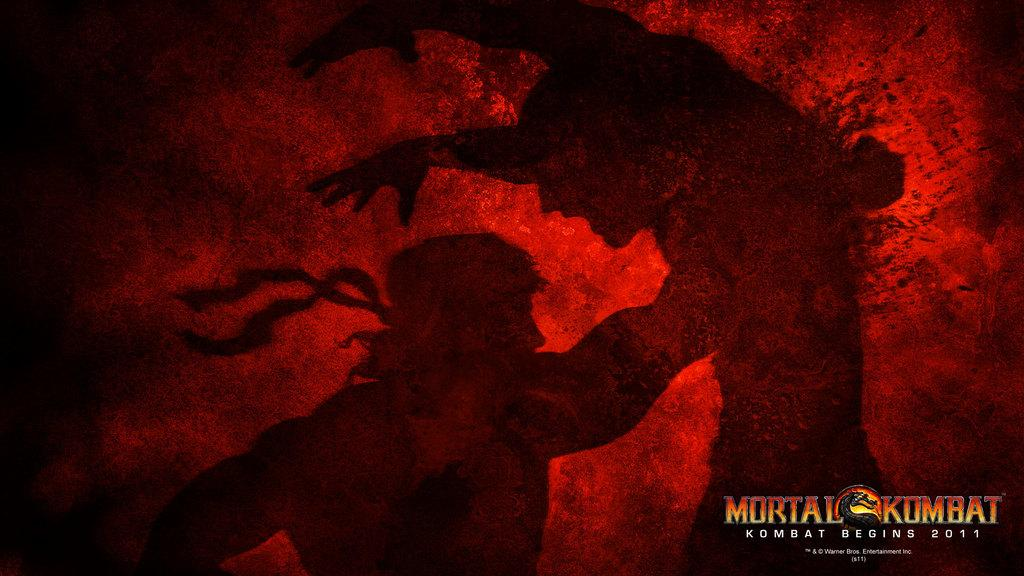<image>
Present a compact description of the photo's key features. two men fighting with a label on the bottom right that says 'mortal kombat' 